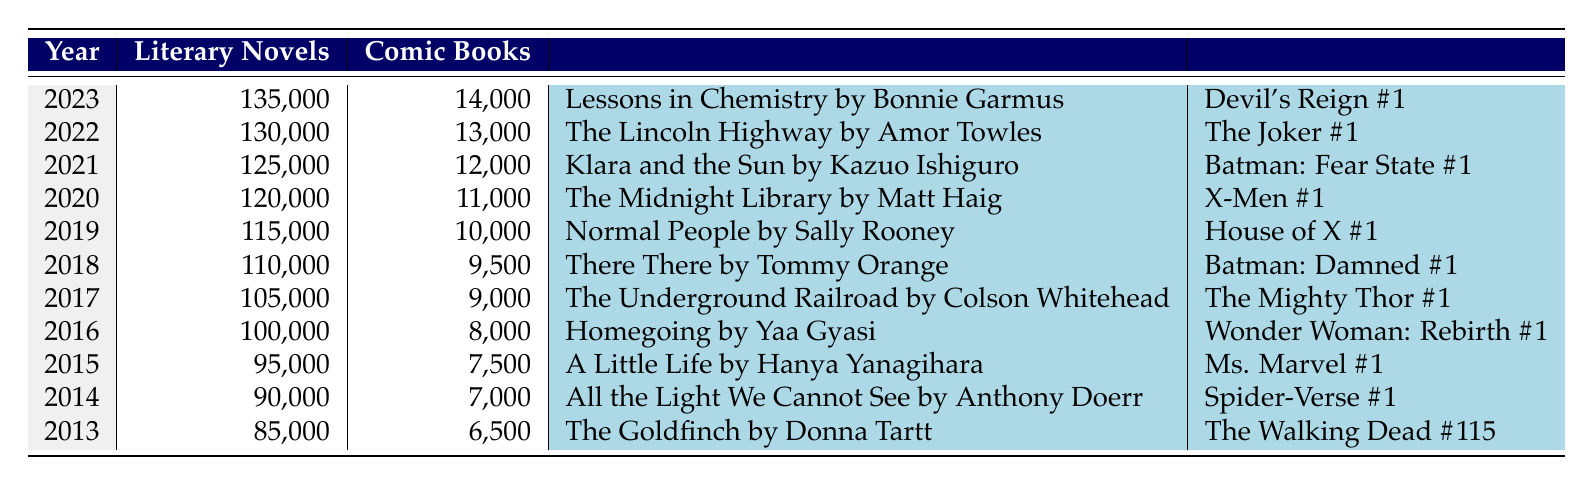What was the year with the highest number of comic books published? Looking through the table, the year with the highest comic book publications is 2023, which shows 14,000 comic books published.
Answer: 2023 What was the notable literary novel in 2020? The table clearly indicates the notable literary novel for the year 2020 was "The Midnight Library" by Matt Haig.
Answer: The Midnight Library by Matt Haig In which year did literary novels see an increase of over 5,000 publications compared to the previous year? By comparing each year's published literary novels, I see that from 2019 to 2020, there was an increase from 115,000 to 120,000, which is a difference of 5,000.
Answer: 2020 How many more literary novels were published in 2022 than in 2013? To find this, I look at the number of literary novels published in 2022 (130,000) and subtract the number from 2013 (85,000). The difference is 130,000 - 85,000 = 45,000.
Answer: 45,000 Is it true that the amount of comic books published has increased each year over the decade? By analyzing the table year by year, I find that the number of comic books published has consistently increased every year from 2013 to 2023.
Answer: Yes What is the average number of literary novels published over the last decade? To calculate the average, I sum the literary novels published from 2013 to 2022: 85,000 + 90,000 + 95,000 + 100,000 + 105,000 + 110,000 + 115,000 + 120,000 + 125,000 + 130,000 + 135,000 = 1,215,000. Then, I divide this total by the number of years (11), resulting in 1,215,000 / 11 = 110,454.5, rounding down gives 110,454.
Answer: 110,454 Which year had a notable comic book that started a significant storyline? Reviewing the notable comic books, "Spider-Verse #1" was released in 2014, which is significant for introducing a notable storyline in the comic book universe.
Answer: 2014 What was the total number of comic books published across all years from 2013 to 2023? To find the total number, I add together all of the comic books published each year: 6,500 + 7,000 + 7,500 + 8,000 + 9,000 + 9,500 + 10,000 + 11,000 + 12,000 + 13,000 + 14,000 = 88,500.
Answer: 88,500 What was the biggest difference in the number of comic books published between any two consecutive years? By examining the comic books published each year, the difference between 2023 (14,000) and 2022 (13,000) is 1,000, which is the largest observed difference across the whole decade.
Answer: 1,000 